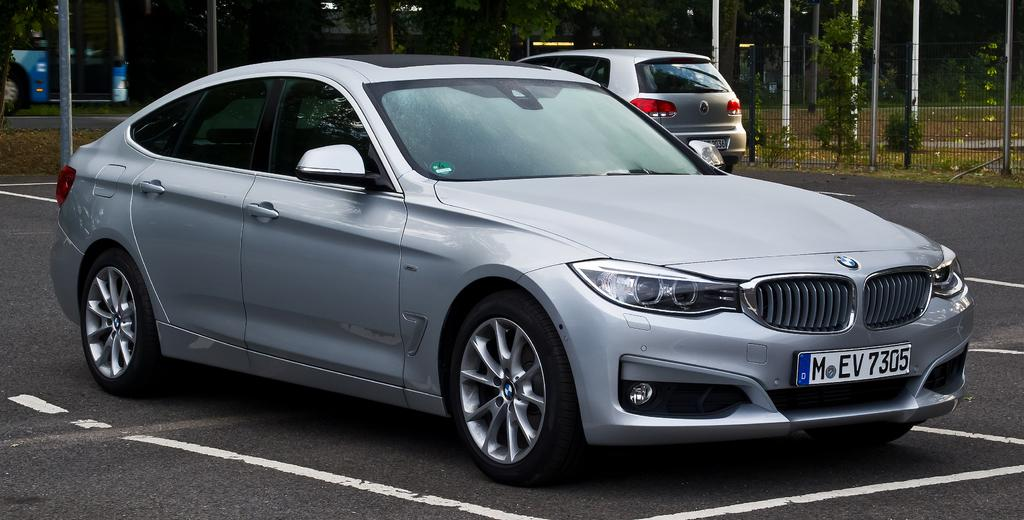What can be seen on the road in the image? There are vehicles on the road in the image. What is visible in the background of the image? There are trees, poles, a fence, and plants in the background of the image. Can you see a hose being used by someone in the image? There is no hose present in the image. Is there a person wearing a crown in the image? There is no person wearing a crown in the image. 